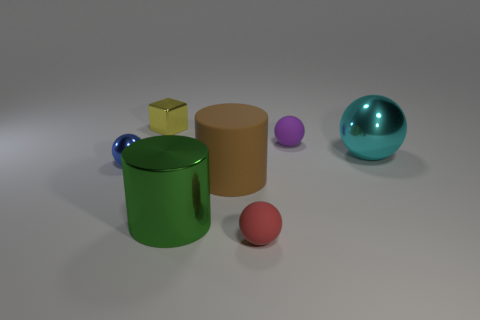Subtract all tiny blue balls. How many balls are left? 3 Add 1 big brown rubber cylinders. How many objects exist? 8 Subtract all green cylinders. How many cylinders are left? 1 Subtract all cylinders. How many objects are left? 5 Subtract 2 spheres. How many spheres are left? 2 Subtract all green cubes. How many purple balls are left? 1 Subtract 0 green spheres. How many objects are left? 7 Subtract all brown spheres. Subtract all blue cylinders. How many spheres are left? 4 Subtract all small metallic balls. Subtract all metallic blocks. How many objects are left? 5 Add 2 big metal cylinders. How many big metal cylinders are left? 3 